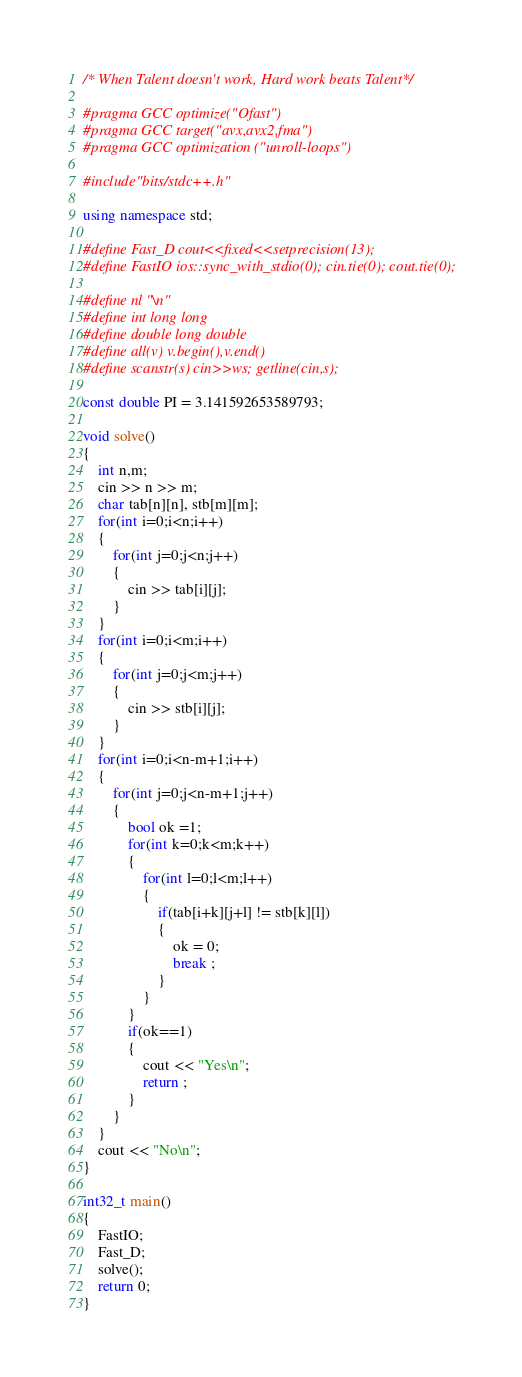<code> <loc_0><loc_0><loc_500><loc_500><_C++_>/* When Talent doesn't work, Hard work beats Talent*/

#pragma GCC optimize("Ofast")
#pragma GCC target("avx,avx2,fma")
#pragma GCC optimization ("unroll-loops")

#include"bits/stdc++.h"

using namespace std;

#define Fast_D cout<<fixed<<setprecision(13);
#define FastIO ios::sync_with_stdio(0); cin.tie(0); cout.tie(0);

#define nl "\n"
#define int long long
#define double long double
#define all(v) v.begin(),v.end()
#define scanstr(s) cin>>ws; getline(cin,s);

const double PI = 3.141592653589793;

void solve()
{
	int n,m;
	cin >> n >> m;
	char tab[n][n], stb[m][m];
	for(int i=0;i<n;i++)
	{
		for(int j=0;j<n;j++)
		{
			cin >> tab[i][j];
		}
	}
	for(int i=0;i<m;i++)
	{
		for(int j=0;j<m;j++)
		{
			cin >> stb[i][j];
		}
	}
	for(int i=0;i<n-m+1;i++)
	{
		for(int j=0;j<n-m+1;j++)
		{
			bool ok =1;
			for(int k=0;k<m;k++)
			{
				for(int l=0;l<m;l++)
				{
					if(tab[i+k][j+l] != stb[k][l])
					{
						ok = 0;
						break ;
					}
				}
			}
			if(ok==1)
			{
				cout << "Yes\n";
				return ;
			}
		}
	}
	cout << "No\n";
}

int32_t main()
{
	FastIO;
	Fast_D;
	solve();
	return 0;
}
</code> 